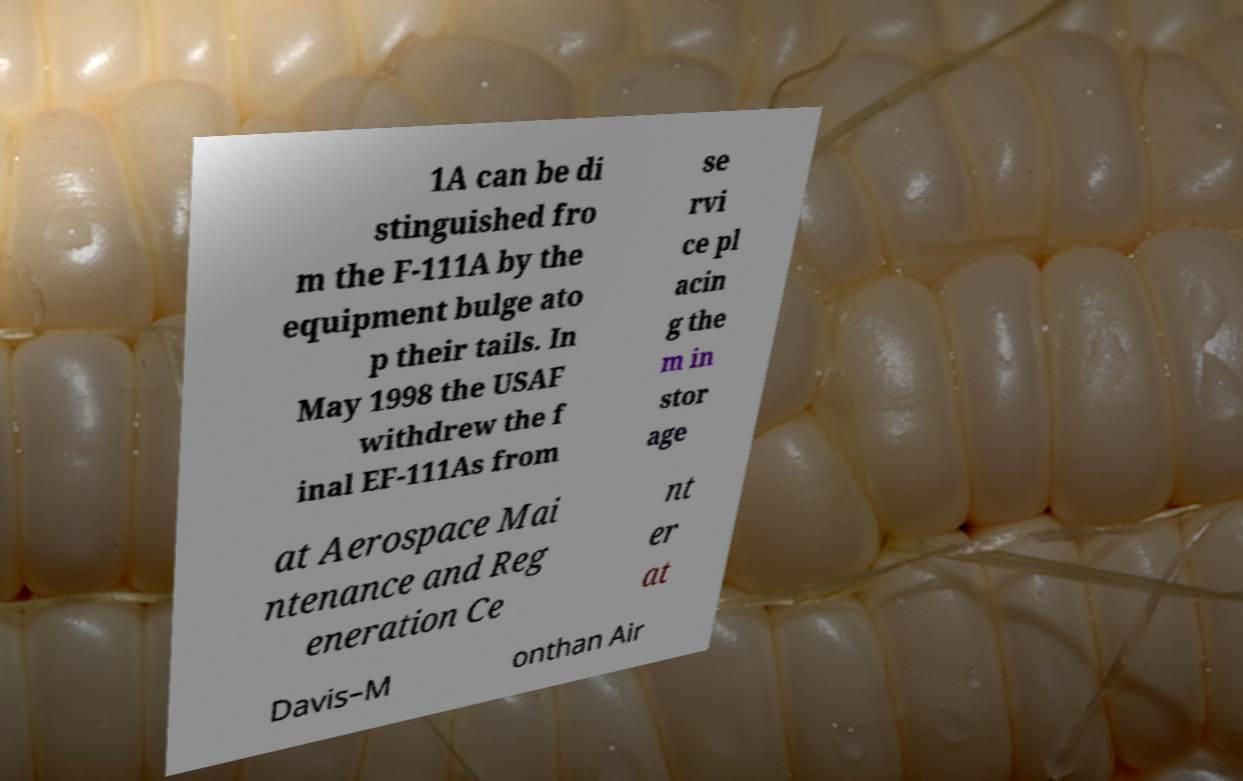Could you extract and type out the text from this image? 1A can be di stinguished fro m the F-111A by the equipment bulge ato p their tails. In May 1998 the USAF withdrew the f inal EF-111As from se rvi ce pl acin g the m in stor age at Aerospace Mai ntenance and Reg eneration Ce nt er at Davis–M onthan Air 